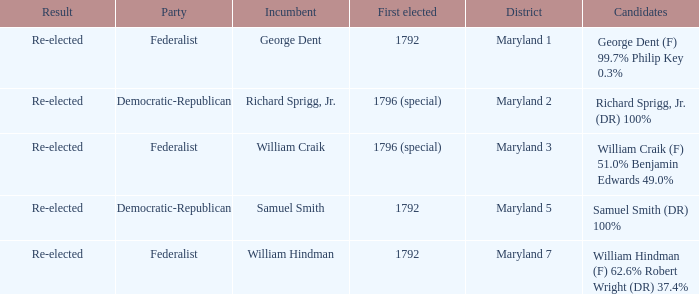Who is the candidates for district maryland 1? George Dent (F) 99.7% Philip Key 0.3%. 